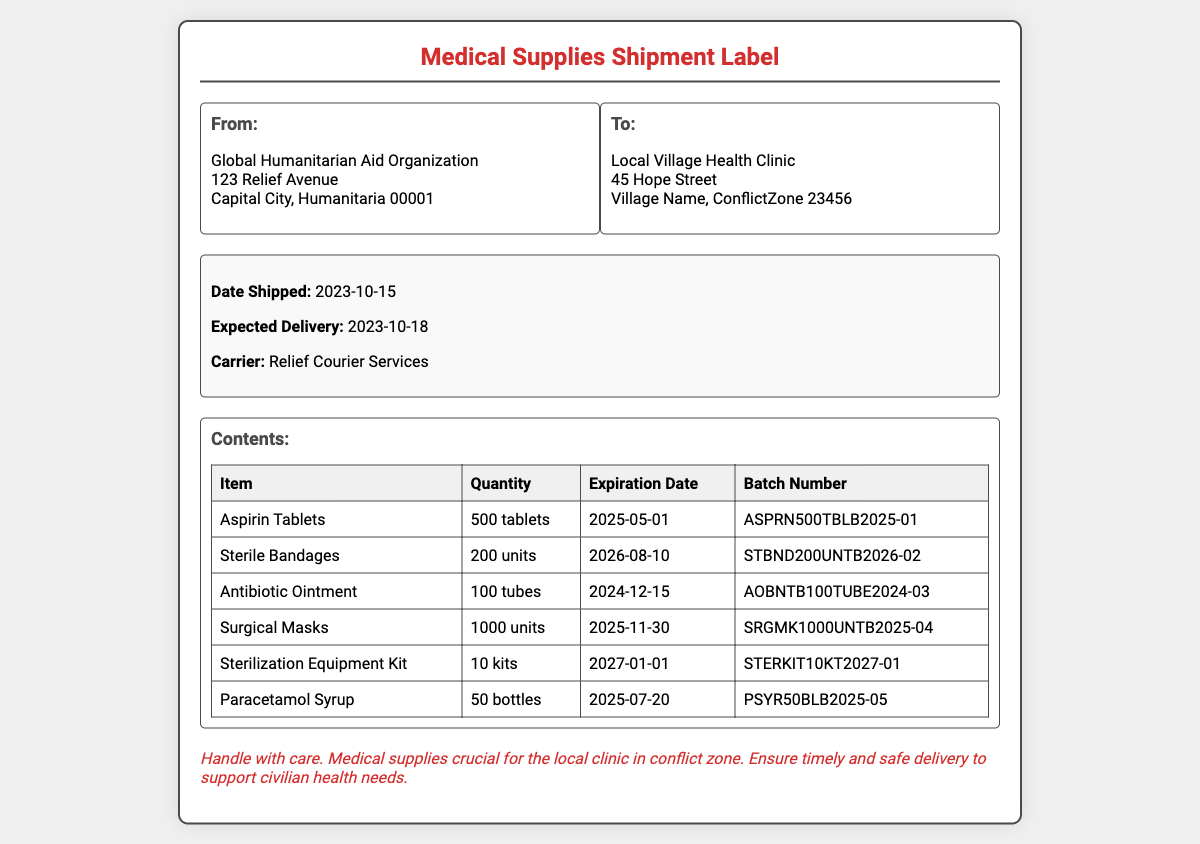What is the name of the organization shipping the medical supplies? The document states that the shipment is from the Global Humanitarian Aid Organization.
Answer: Global Humanitarian Aid Organization What is the expected delivery date? The expected delivery date is provided in the shipment details as October 18, 2023.
Answer: 2023-10-18 How many units of sterile bandages are included in the shipment? The table shows that there are 200 units of sterile bandages included in the shipment.
Answer: 200 units What is the expiration date for the antibiotic ointment? The expiration date for the antibiotic ointment is mentioned in the table as December 15, 2024.
Answer: 2024-12-15 How many surgical masks are part of the shipment? The quantity of surgical masks is listed as 1000 units in the contents table.
Answer: 1000 units Which item has the earliest expiration date? By examining the expiration dates, the item with the earliest date is the antibiotic ointment.
Answer: Antibiotic Ointment Who is the recipient of this shipment? The recipient is specified in the address section as the Local Village Health Clinic.
Answer: Local Village Health Clinic What is the batch number for the sterilization equipment kit? The batch number for the sterilization equipment kit is provided in the table as STERKIT10KT2027-01.
Answer: STERKIT10KT2027-01 What is the special note regarding the handling of the shipment? The document includes a note emphasizing the need to handle the shipment with care as it contains crucial medical supplies.
Answer: Handle with care 